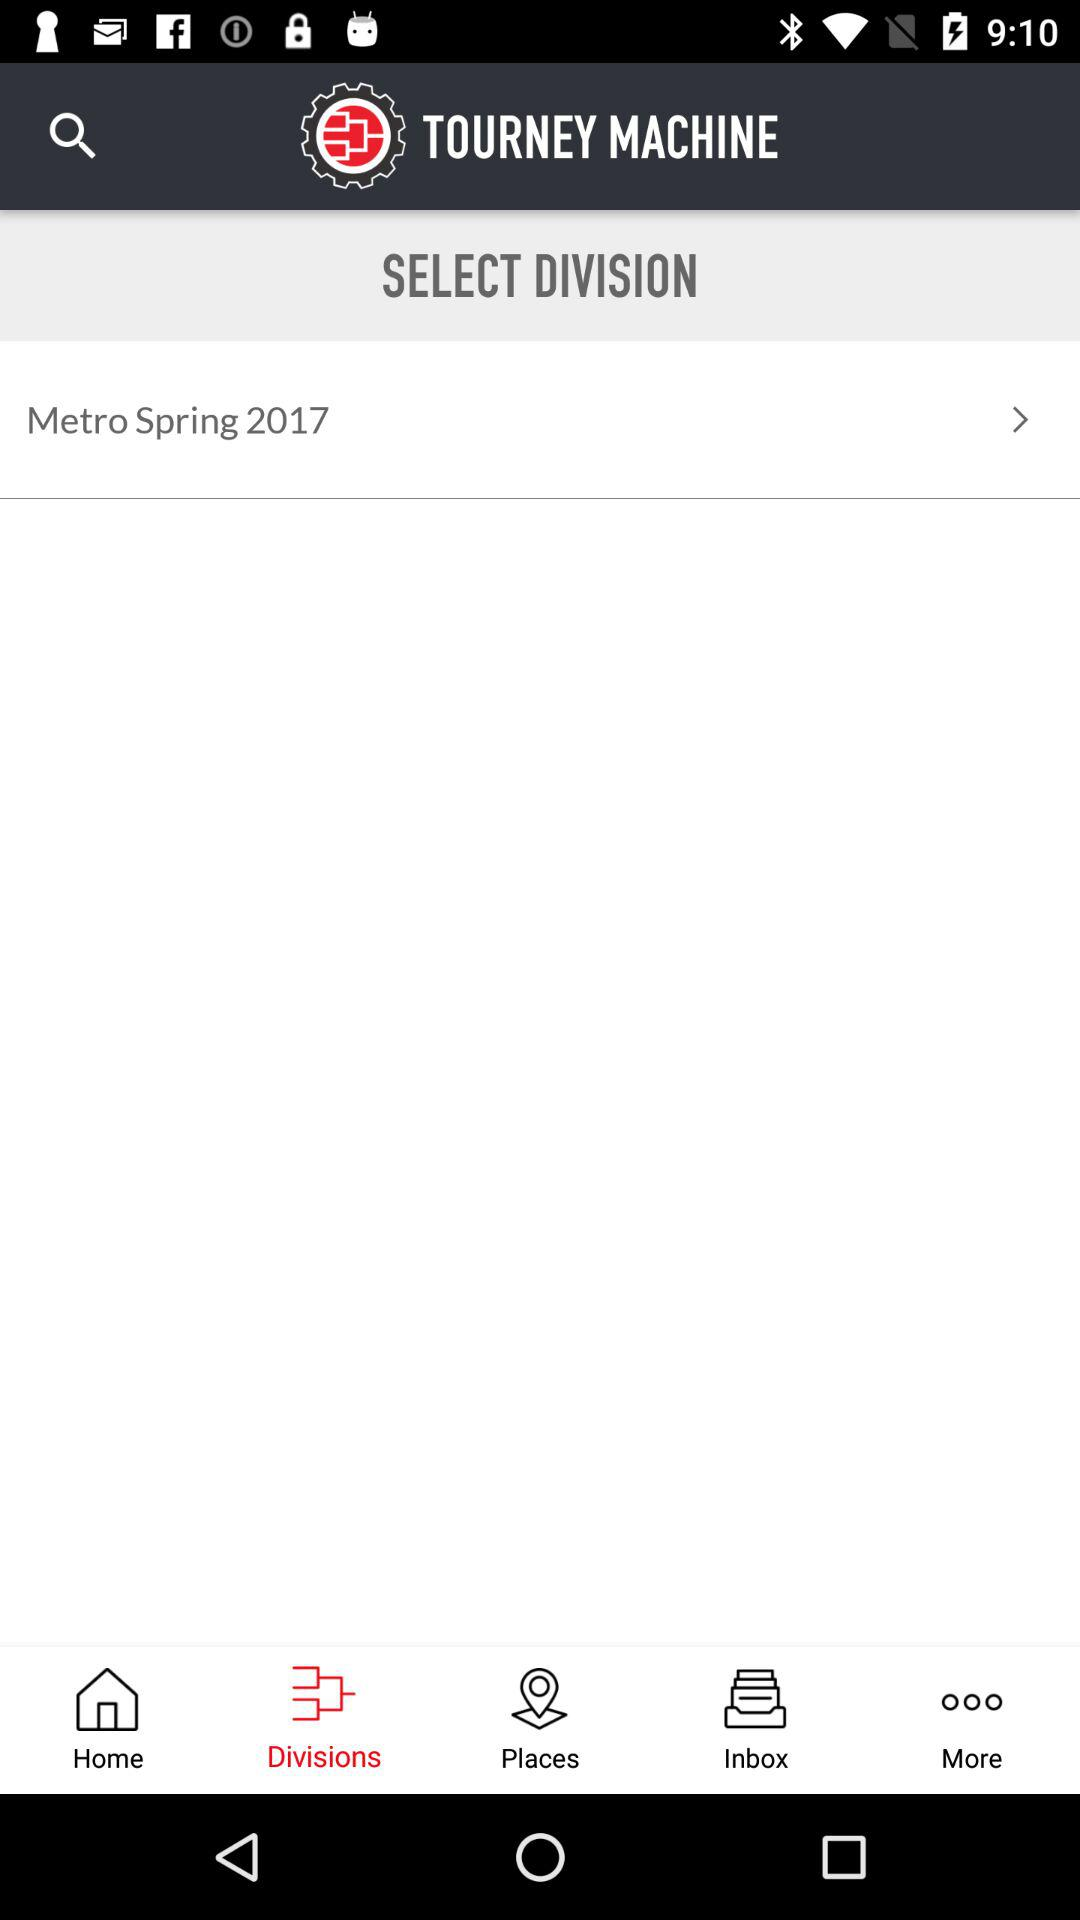What is the name of the application? The name of the application is "TOURNEY MACHINE". 